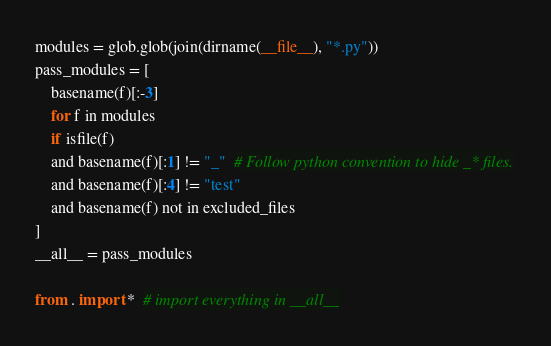Convert code to text. <code><loc_0><loc_0><loc_500><loc_500><_Python_>modules = glob.glob(join(dirname(__file__), "*.py"))
pass_modules = [
    basename(f)[:-3]
    for f in modules
    if isfile(f)
    and basename(f)[:1] != "_"  # Follow python convention to hide _* files.
    and basename(f)[:4] != "test"
    and basename(f) not in excluded_files
]
__all__ = pass_modules

from . import *  # import everything in __all__
</code> 